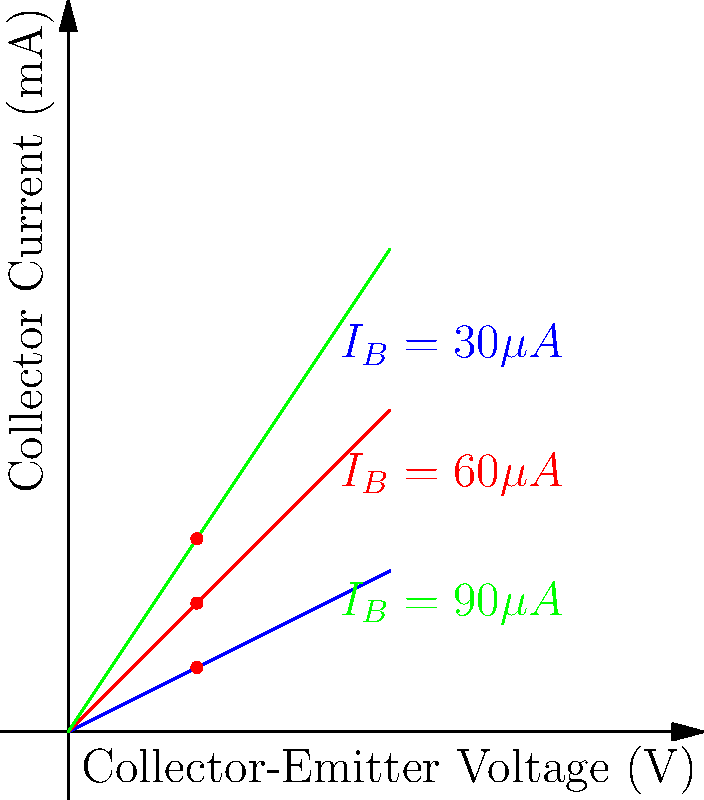Based on the transistor characteristic curves shown in the graph, what is the approximate value of the transistor's current gain ($\beta$ or h$_{FE}$) when the collector-emitter voltage is 2V and the collector current is 2mA? To find the current gain ($\beta$ or h$_{FE}$), we need to follow these steps:

1. Identify the operating point: At $V_{CE} = 2V$ and $I_C = 2mA$, we are on the middle (red) curve.

2. Determine the base current ($I_B$) for this curve: The red curve is labeled as $I_B = 60\mu A$.

3. Recall the formula for current gain: $\beta = \frac{I_C}{I_B}$

4. Calculate $\beta$:
   $\beta = \frac{I_C}{I_B} = \frac{2mA}{60\mu A} = \frac{2 \times 10^{-3}}{60 \times 10^{-6}} = \frac{2000}{60} \approx 33.33$

5. Round to the nearest whole number: $\beta \approx 33$

Therefore, the approximate current gain ($\beta$) at the given operating point is 33.
Answer: 33 